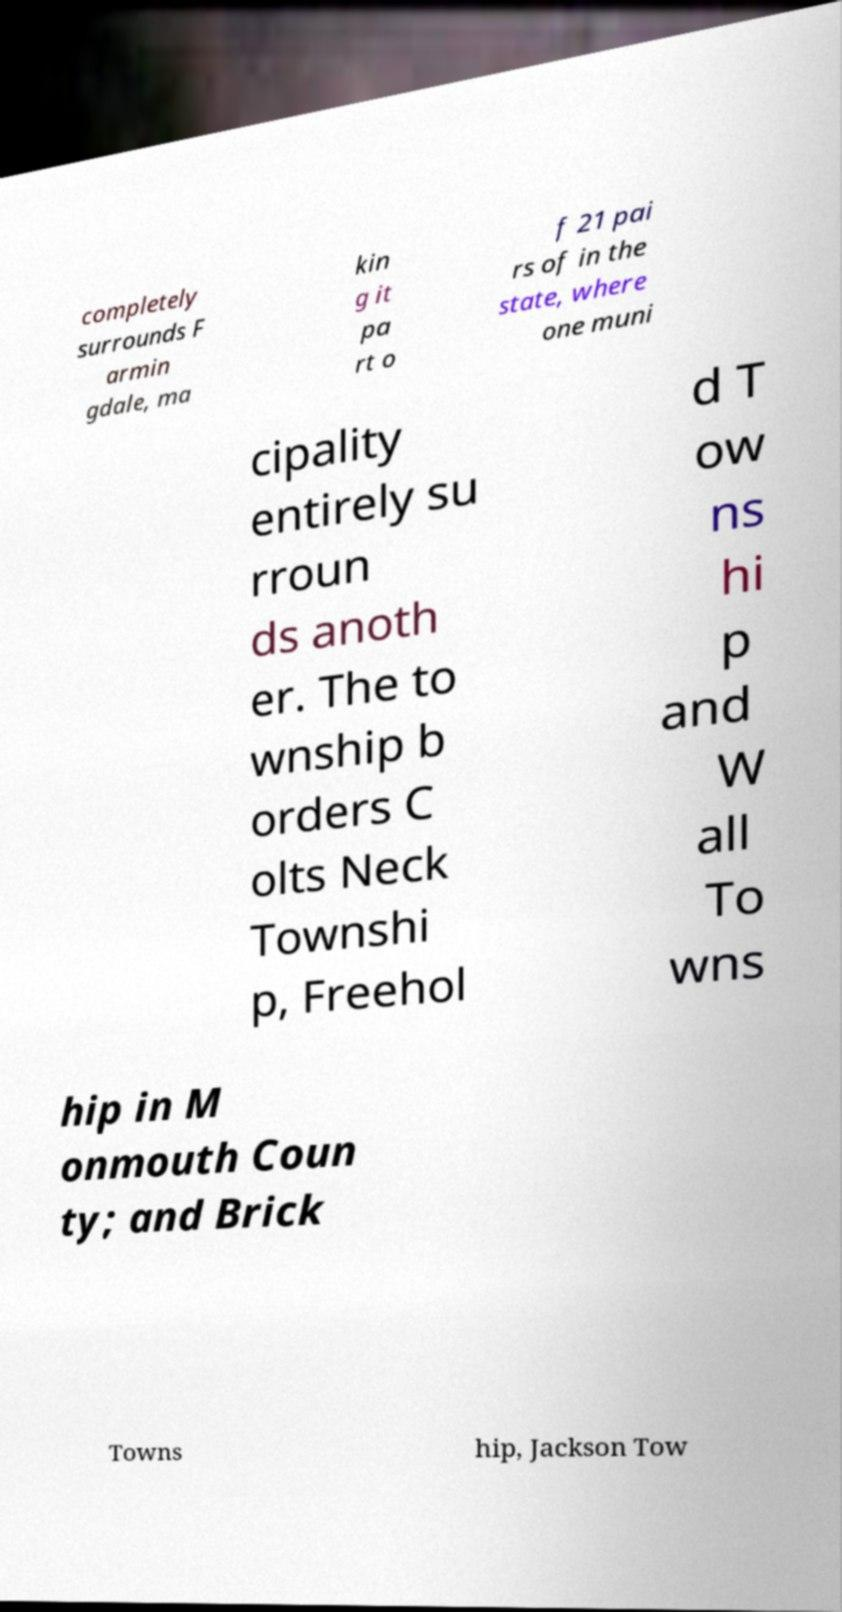Can you accurately transcribe the text from the provided image for me? completely surrounds F armin gdale, ma kin g it pa rt o f 21 pai rs of in the state, where one muni cipality entirely su rroun ds anoth er. The to wnship b orders C olts Neck Townshi p, Freehol d T ow ns hi p and W all To wns hip in M onmouth Coun ty; and Brick Towns hip, Jackson Tow 